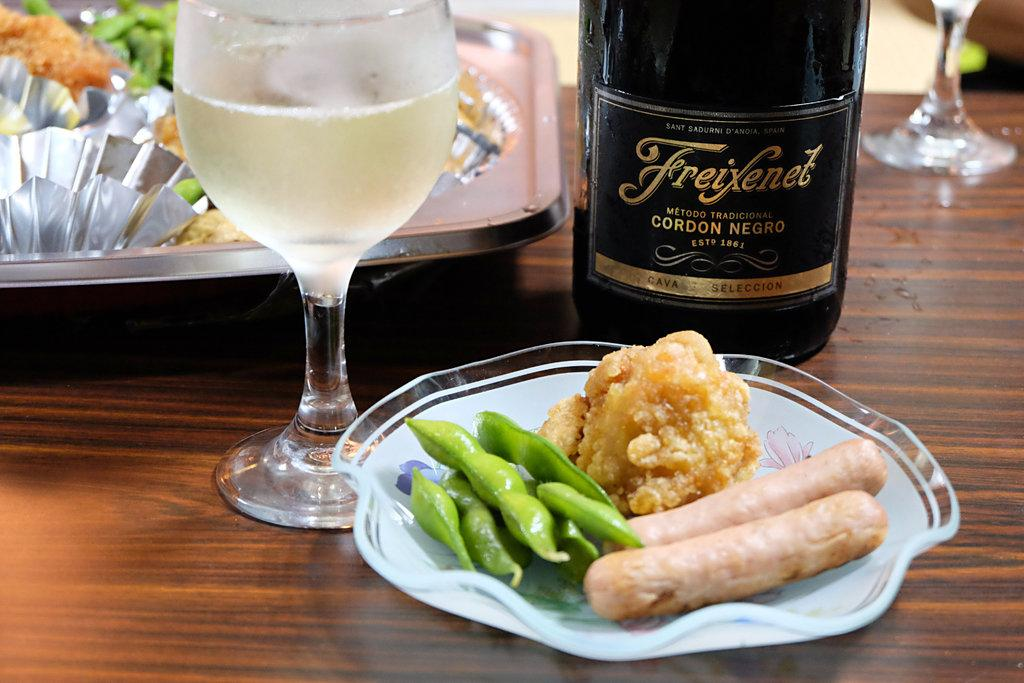<image>
Offer a succinct explanation of the picture presented. A plate with edamame and sausages is in front of a bottle of Cordon Negro. 